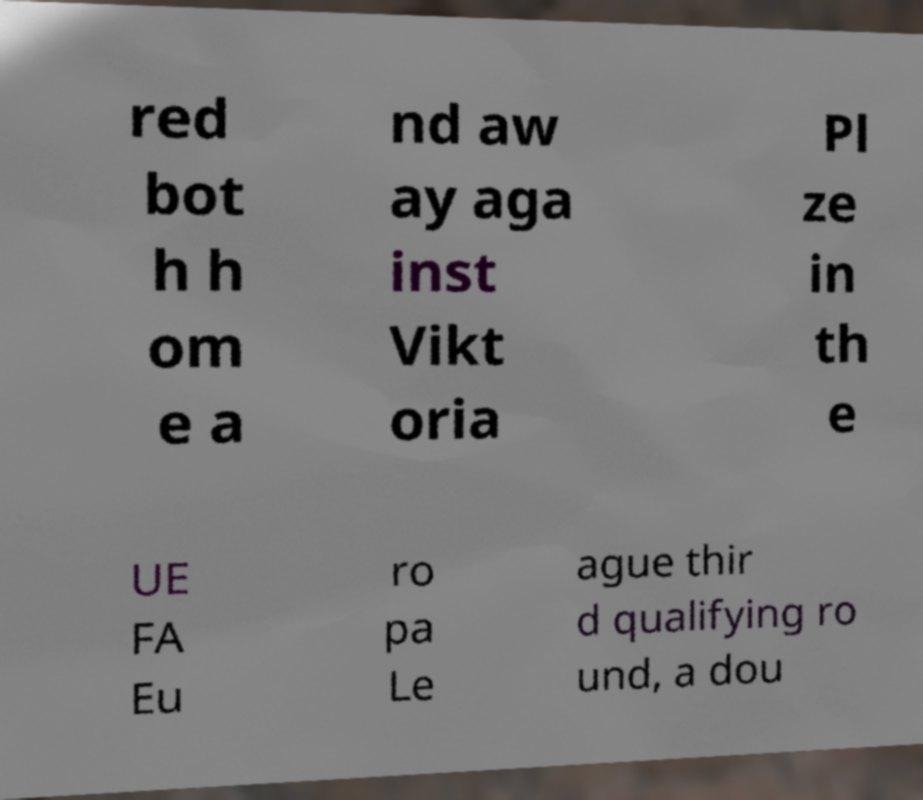Could you extract and type out the text from this image? red bot h h om e a nd aw ay aga inst Vikt oria Pl ze in th e UE FA Eu ro pa Le ague thir d qualifying ro und, a dou 